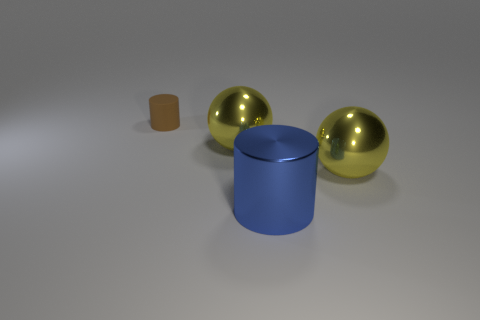Add 3 big blue shiny things. How many objects exist? 7 Subtract 1 cylinders. How many cylinders are left? 1 Subtract 0 gray cylinders. How many objects are left? 4 Subtract all green spheres. Subtract all blue cubes. How many spheres are left? 2 Subtract all red balls. How many brown cylinders are left? 1 Subtract all large green metal things. Subtract all big blue cylinders. How many objects are left? 3 Add 1 big shiny objects. How many big shiny objects are left? 4 Add 2 small matte cylinders. How many small matte cylinders exist? 3 